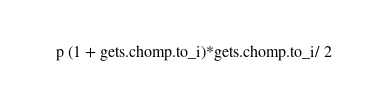Convert code to text. <code><loc_0><loc_0><loc_500><loc_500><_Ruby_>p (1 + gets.chomp.to_i)*gets.chomp.to_i/ 2</code> 